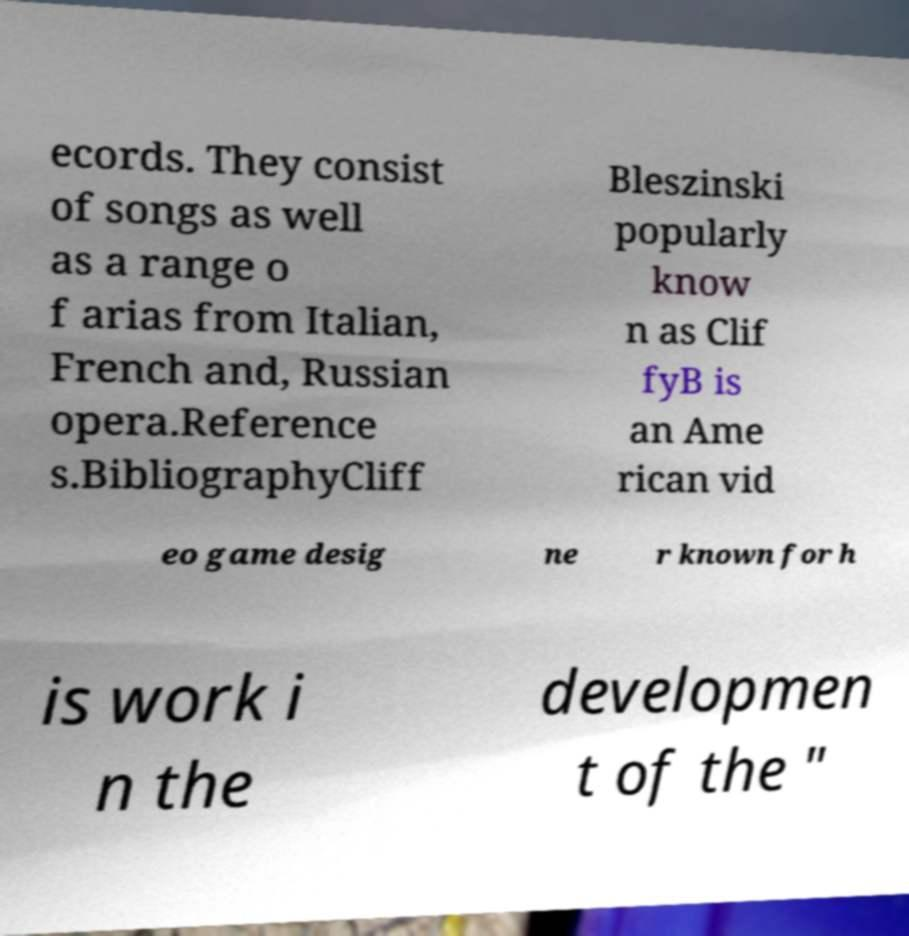Could you assist in decoding the text presented in this image and type it out clearly? ecords. They consist of songs as well as a range o f arias from Italian, French and, Russian opera.Reference s.BibliographyCliff Bleszinski popularly know n as Clif fyB is an Ame rican vid eo game desig ne r known for h is work i n the developmen t of the " 